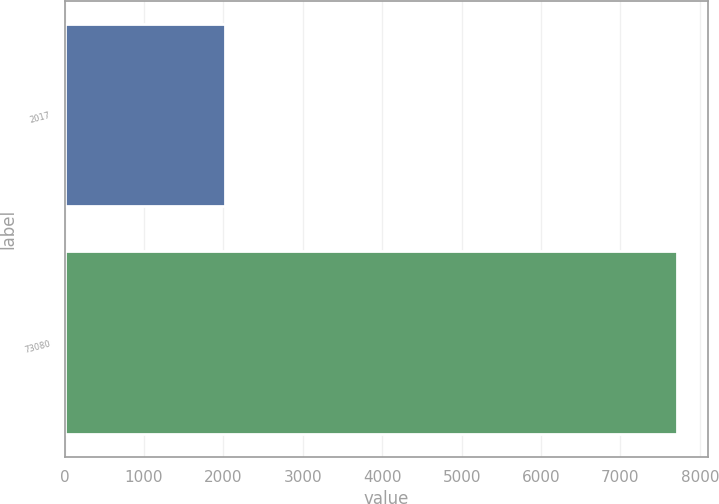<chart> <loc_0><loc_0><loc_500><loc_500><bar_chart><fcel>2017<fcel>73080<nl><fcel>2017<fcel>7716<nl></chart> 